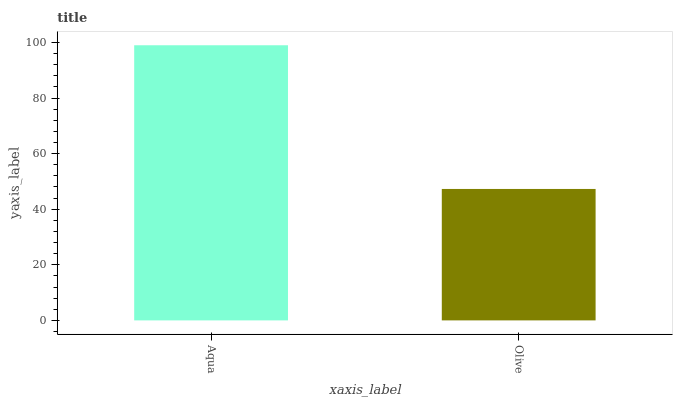Is Olive the minimum?
Answer yes or no. Yes. Is Aqua the maximum?
Answer yes or no. Yes. Is Olive the maximum?
Answer yes or no. No. Is Aqua greater than Olive?
Answer yes or no. Yes. Is Olive less than Aqua?
Answer yes or no. Yes. Is Olive greater than Aqua?
Answer yes or no. No. Is Aqua less than Olive?
Answer yes or no. No. Is Aqua the high median?
Answer yes or no. Yes. Is Olive the low median?
Answer yes or no. Yes. Is Olive the high median?
Answer yes or no. No. Is Aqua the low median?
Answer yes or no. No. 